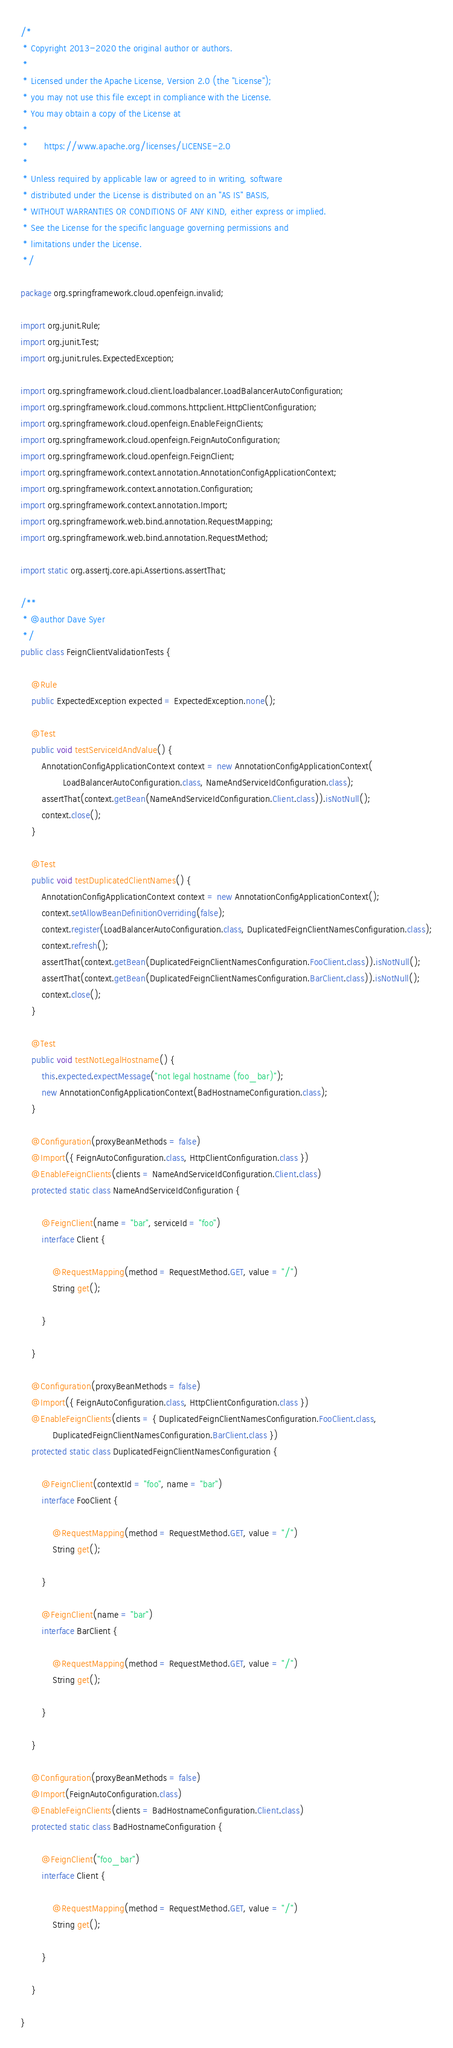<code> <loc_0><loc_0><loc_500><loc_500><_Java_>/*
 * Copyright 2013-2020 the original author or authors.
 *
 * Licensed under the Apache License, Version 2.0 (the "License");
 * you may not use this file except in compliance with the License.
 * You may obtain a copy of the License at
 *
 *      https://www.apache.org/licenses/LICENSE-2.0
 *
 * Unless required by applicable law or agreed to in writing, software
 * distributed under the License is distributed on an "AS IS" BASIS,
 * WITHOUT WARRANTIES OR CONDITIONS OF ANY KIND, either express or implied.
 * See the License for the specific language governing permissions and
 * limitations under the License.
 */

package org.springframework.cloud.openfeign.invalid;

import org.junit.Rule;
import org.junit.Test;
import org.junit.rules.ExpectedException;

import org.springframework.cloud.client.loadbalancer.LoadBalancerAutoConfiguration;
import org.springframework.cloud.commons.httpclient.HttpClientConfiguration;
import org.springframework.cloud.openfeign.EnableFeignClients;
import org.springframework.cloud.openfeign.FeignAutoConfiguration;
import org.springframework.cloud.openfeign.FeignClient;
import org.springframework.context.annotation.AnnotationConfigApplicationContext;
import org.springframework.context.annotation.Configuration;
import org.springframework.context.annotation.Import;
import org.springframework.web.bind.annotation.RequestMapping;
import org.springframework.web.bind.annotation.RequestMethod;

import static org.assertj.core.api.Assertions.assertThat;

/**
 * @author Dave Syer
 */
public class FeignClientValidationTests {

	@Rule
	public ExpectedException expected = ExpectedException.none();

	@Test
	public void testServiceIdAndValue() {
		AnnotationConfigApplicationContext context = new AnnotationConfigApplicationContext(
				LoadBalancerAutoConfiguration.class, NameAndServiceIdConfiguration.class);
		assertThat(context.getBean(NameAndServiceIdConfiguration.Client.class)).isNotNull();
		context.close();
	}

	@Test
	public void testDuplicatedClientNames() {
		AnnotationConfigApplicationContext context = new AnnotationConfigApplicationContext();
		context.setAllowBeanDefinitionOverriding(false);
		context.register(LoadBalancerAutoConfiguration.class, DuplicatedFeignClientNamesConfiguration.class);
		context.refresh();
		assertThat(context.getBean(DuplicatedFeignClientNamesConfiguration.FooClient.class)).isNotNull();
		assertThat(context.getBean(DuplicatedFeignClientNamesConfiguration.BarClient.class)).isNotNull();
		context.close();
	}

	@Test
	public void testNotLegalHostname() {
		this.expected.expectMessage("not legal hostname (foo_bar)");
		new AnnotationConfigApplicationContext(BadHostnameConfiguration.class);
	}

	@Configuration(proxyBeanMethods = false)
	@Import({ FeignAutoConfiguration.class, HttpClientConfiguration.class })
	@EnableFeignClients(clients = NameAndServiceIdConfiguration.Client.class)
	protected static class NameAndServiceIdConfiguration {

		@FeignClient(name = "bar", serviceId = "foo")
		interface Client {

			@RequestMapping(method = RequestMethod.GET, value = "/")
			String get();

		}

	}

	@Configuration(proxyBeanMethods = false)
	@Import({ FeignAutoConfiguration.class, HttpClientConfiguration.class })
	@EnableFeignClients(clients = { DuplicatedFeignClientNamesConfiguration.FooClient.class,
			DuplicatedFeignClientNamesConfiguration.BarClient.class })
	protected static class DuplicatedFeignClientNamesConfiguration {

		@FeignClient(contextId = "foo", name = "bar")
		interface FooClient {

			@RequestMapping(method = RequestMethod.GET, value = "/")
			String get();

		}

		@FeignClient(name = "bar")
		interface BarClient {

			@RequestMapping(method = RequestMethod.GET, value = "/")
			String get();

		}

	}

	@Configuration(proxyBeanMethods = false)
	@Import(FeignAutoConfiguration.class)
	@EnableFeignClients(clients = BadHostnameConfiguration.Client.class)
	protected static class BadHostnameConfiguration {

		@FeignClient("foo_bar")
		interface Client {

			@RequestMapping(method = RequestMethod.GET, value = "/")
			String get();

		}

	}

}
</code> 